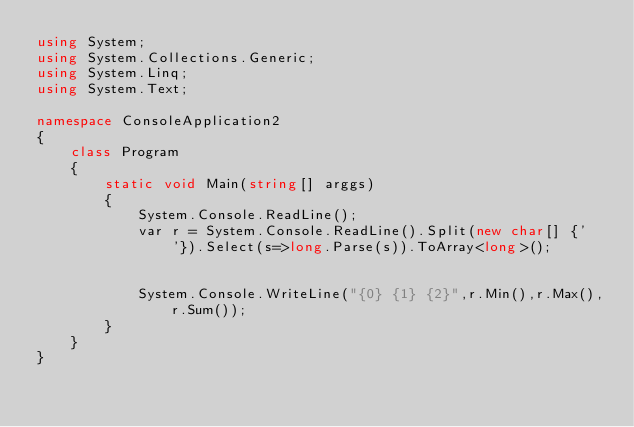Convert code to text. <code><loc_0><loc_0><loc_500><loc_500><_C#_>using System;
using System.Collections.Generic;
using System.Linq;
using System.Text;

namespace ConsoleApplication2
{
    class Program
    {
        static void Main(string[] arggs)
        {
            System.Console.ReadLine();
            var r = System.Console.ReadLine().Split(new char[] {' '}).Select(s=>long.Parse(s)).ToArray<long>();


            System.Console.WriteLine("{0} {1} {2}",r.Min(),r.Max(),r.Sum());
        }
    }
}</code> 